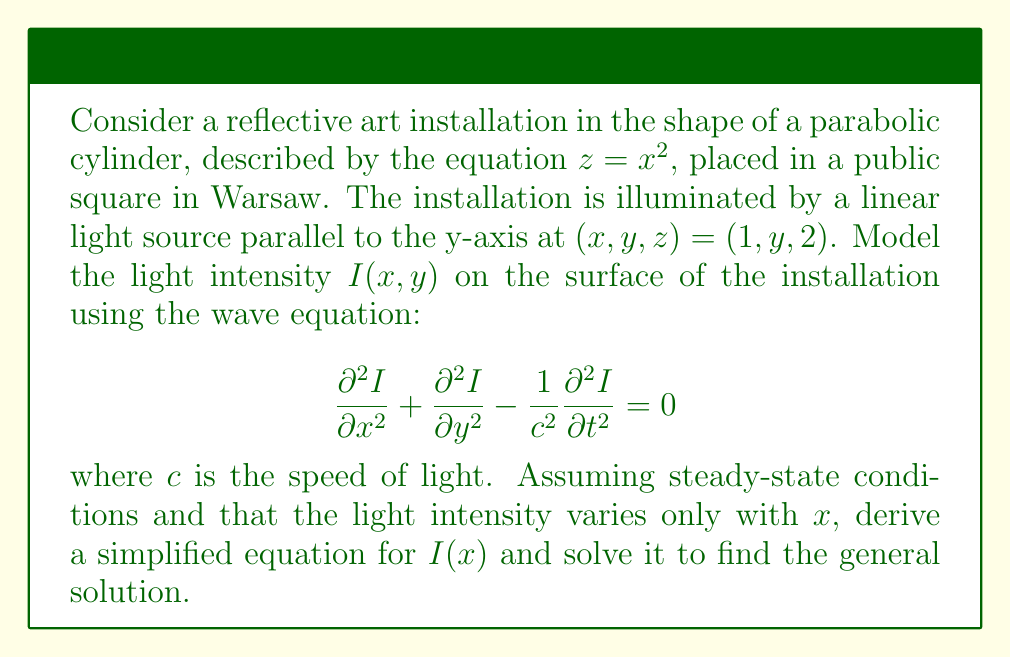Can you solve this math problem? Let's approach this step-by-step:

1) First, we simplify the wave equation based on our assumptions:
   - Steady-state conditions mean $\frac{\partial I}{\partial t} = 0$
   - Light intensity varies only with $x$, so $\frac{\partial I}{\partial y} = 0$

2) This reduces our equation to:

   $$\frac{d^2 I}{dx^2} = 0$$

3) This is a second-order ordinary differential equation. The general solution is:

   $$I(x) = Ax + B$$

   where $A$ and $B$ are constants to be determined by boundary conditions.

4) To find these constants, we would need additional information about the light source and the reflective properties of the installation. However, this general solution tells us that the light intensity varies linearly with $x$ on the surface of the parabolic cylinder.

5) This linear variation of light intensity could create an interesting visual effect on the art installation, potentially highlighting the parabolic shape in a unique way that could be visually striking for viewers in the Warsaw public square.
Answer: $I(x) = Ax + B$, where $A$ and $B$ are constants determined by boundary conditions. 